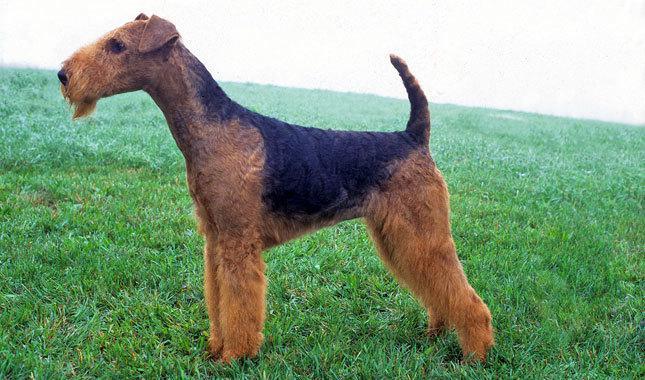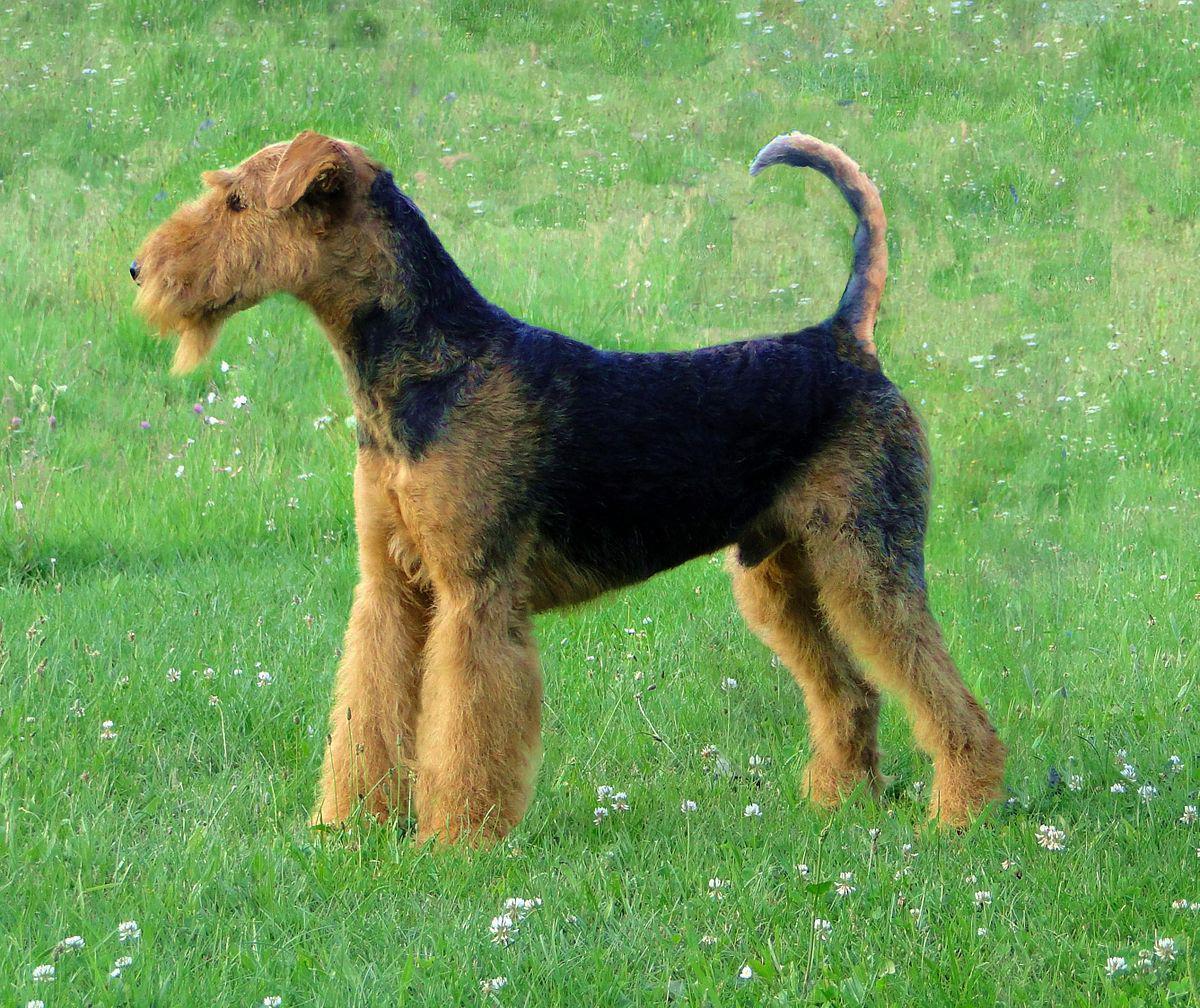The first image is the image on the left, the second image is the image on the right. Given the left and right images, does the statement "Every image shows exactly one dog, and in images where the dog is standing outside in grass the dog is facing the left." hold true? Answer yes or no. Yes. 